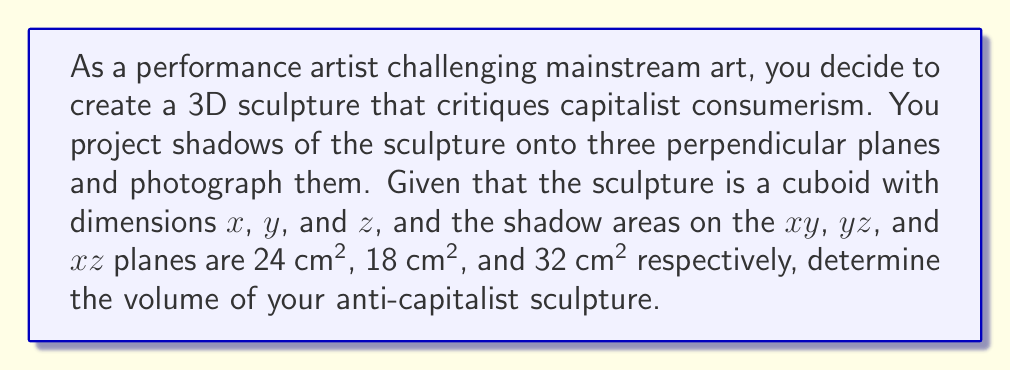Can you solve this math problem? Let's approach this problem step-by-step:

1) The shadow areas give us information about the dimensions of the cuboid:
   - Shadow on $xy$ plane: $x \cdot y = 24$ cm²
   - Shadow on $yz$ plane: $y \cdot z = 18$ cm²
   - Shadow on $xz$ plane: $x \cdot z = 32$ cm²

2) We can express these relationships as equations:
   $$xy = 24$$
   $$yz = 18$$
   $$xz = 32$$

3) To find the volume, we need to multiply these dimensions: $V = x \cdot y \cdot z$

4) We can rearrange our equations to express $x$, $y$, and $z$ in terms of each other:
   $$x = \frac{24}{y}$$
   $$z = \frac{18}{y}$$

5) Substituting these into the third equation:
   $$\frac{24}{y} \cdot \frac{18}{y} = 32$$

6) Simplifying:
   $$\frac{432}{y^2} = 32$$
   $$y^2 = \frac{432}{32} = 13.5$$
   $$y = \sqrt{13.5} = 3.674$$

7) Now we can find $x$ and $z$:
   $$x = \frac{24}{3.674} = 6.532$$
   $$z = \frac{18}{3.674} = 4.899$$

8) The volume is therefore:
   $$V = x \cdot y \cdot z = 6.532 \cdot 3.674 \cdot 4.899 = 117.6$$ cm³
Answer: 117.6 cm³ 